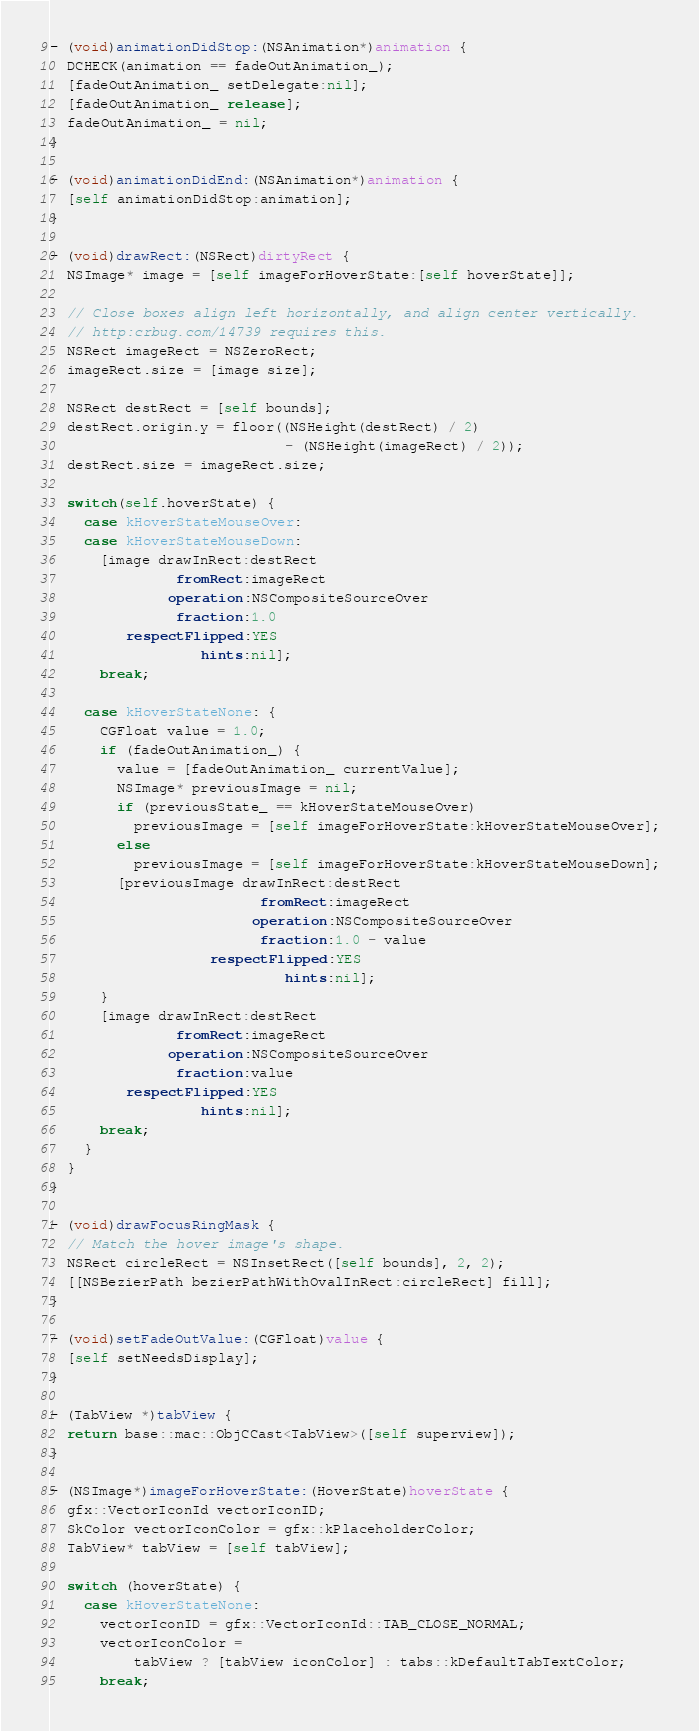Convert code to text. <code><loc_0><loc_0><loc_500><loc_500><_ObjectiveC_>
- (void)animationDidStop:(NSAnimation*)animation {
  DCHECK(animation == fadeOutAnimation_);
  [fadeOutAnimation_ setDelegate:nil];
  [fadeOutAnimation_ release];
  fadeOutAnimation_ = nil;
}

- (void)animationDidEnd:(NSAnimation*)animation {
  [self animationDidStop:animation];
}

- (void)drawRect:(NSRect)dirtyRect {
  NSImage* image = [self imageForHoverState:[self hoverState]];

  // Close boxes align left horizontally, and align center vertically.
  // http:crbug.com/14739 requires this.
  NSRect imageRect = NSZeroRect;
  imageRect.size = [image size];

  NSRect destRect = [self bounds];
  destRect.origin.y = floor((NSHeight(destRect) / 2)
                            - (NSHeight(imageRect) / 2));
  destRect.size = imageRect.size;

  switch(self.hoverState) {
    case kHoverStateMouseOver:
    case kHoverStateMouseDown:
      [image drawInRect:destRect
               fromRect:imageRect
              operation:NSCompositeSourceOver
               fraction:1.0
         respectFlipped:YES
                  hints:nil];
      break;

    case kHoverStateNone: {
      CGFloat value = 1.0;
      if (fadeOutAnimation_) {
        value = [fadeOutAnimation_ currentValue];
        NSImage* previousImage = nil;
        if (previousState_ == kHoverStateMouseOver)
          previousImage = [self imageForHoverState:kHoverStateMouseOver];
        else
          previousImage = [self imageForHoverState:kHoverStateMouseDown];
        [previousImage drawInRect:destRect
                         fromRect:imageRect
                        operation:NSCompositeSourceOver
                         fraction:1.0 - value
                   respectFlipped:YES
                            hints:nil];
      }
      [image drawInRect:destRect
               fromRect:imageRect
              operation:NSCompositeSourceOver
               fraction:value
         respectFlipped:YES
                  hints:nil];
      break;
    }
  }
}

- (void)drawFocusRingMask {
  // Match the hover image's shape.
  NSRect circleRect = NSInsetRect([self bounds], 2, 2);
  [[NSBezierPath bezierPathWithOvalInRect:circleRect] fill];
}

- (void)setFadeOutValue:(CGFloat)value {
  [self setNeedsDisplay];
}

- (TabView *)tabView {
  return base::mac::ObjCCast<TabView>([self superview]);
}

- (NSImage*)imageForHoverState:(HoverState)hoverState {
  gfx::VectorIconId vectorIconID;
  SkColor vectorIconColor = gfx::kPlaceholderColor;
  TabView* tabView = [self tabView];

  switch (hoverState) {
    case kHoverStateNone:
      vectorIconID = gfx::VectorIconId::TAB_CLOSE_NORMAL;
      vectorIconColor =
          tabView ? [tabView iconColor] : tabs::kDefaultTabTextColor;
      break;</code> 